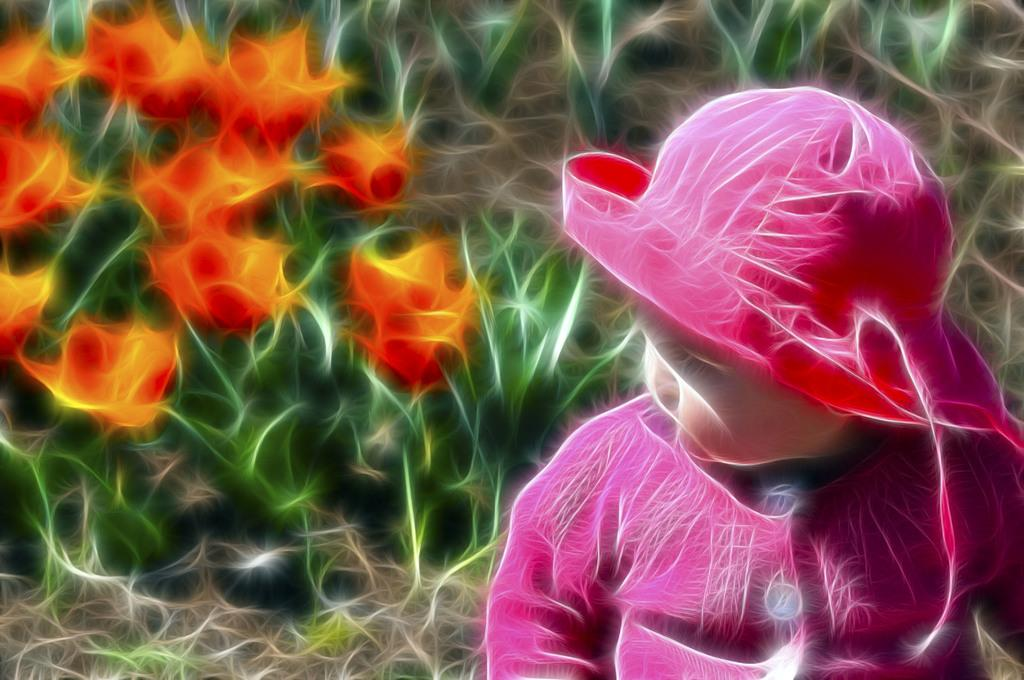What type of image is being described? The image is an edited picture. What is the main subject of the image? There is a baby in the image. What is the baby wearing? The baby is wearing a pink hat. How would you describe the background of the image? The background of the image contains green, red, and orange colors. What type of harmony can be heard in the background of the image? There is no audible harmony in the image, as it is a still picture. Can you describe the baby's voice in the image? The image is a still picture, so there is no audible voice present. 